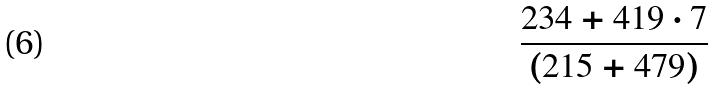<formula> <loc_0><loc_0><loc_500><loc_500>\frac { 2 3 4 + 4 1 9 \cdot 7 } { ( 2 1 5 + 4 7 9 ) }</formula> 